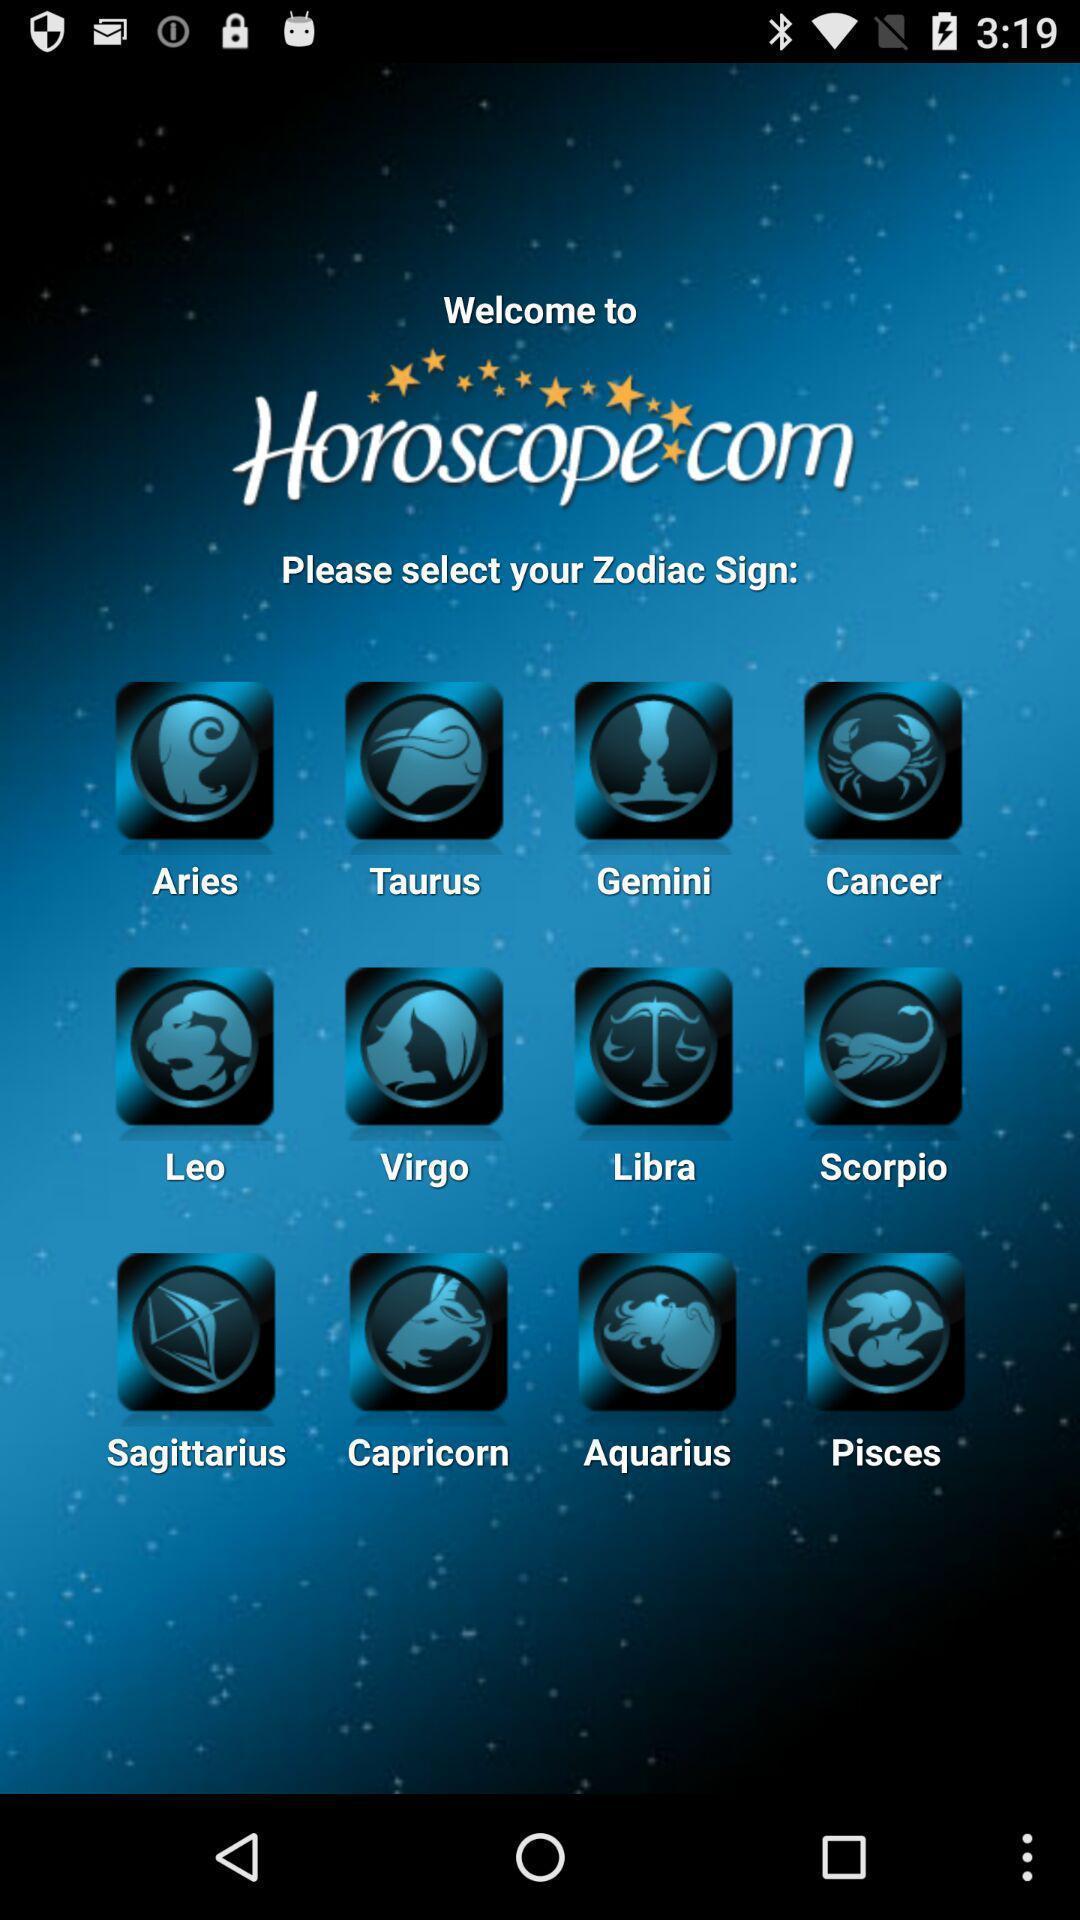Give me a summary of this screen capture. Welcome page. 